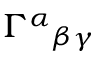Convert formula to latex. <formula><loc_0><loc_0><loc_500><loc_500>\Gamma ^ { \alpha _ { \beta \gamma }</formula> 